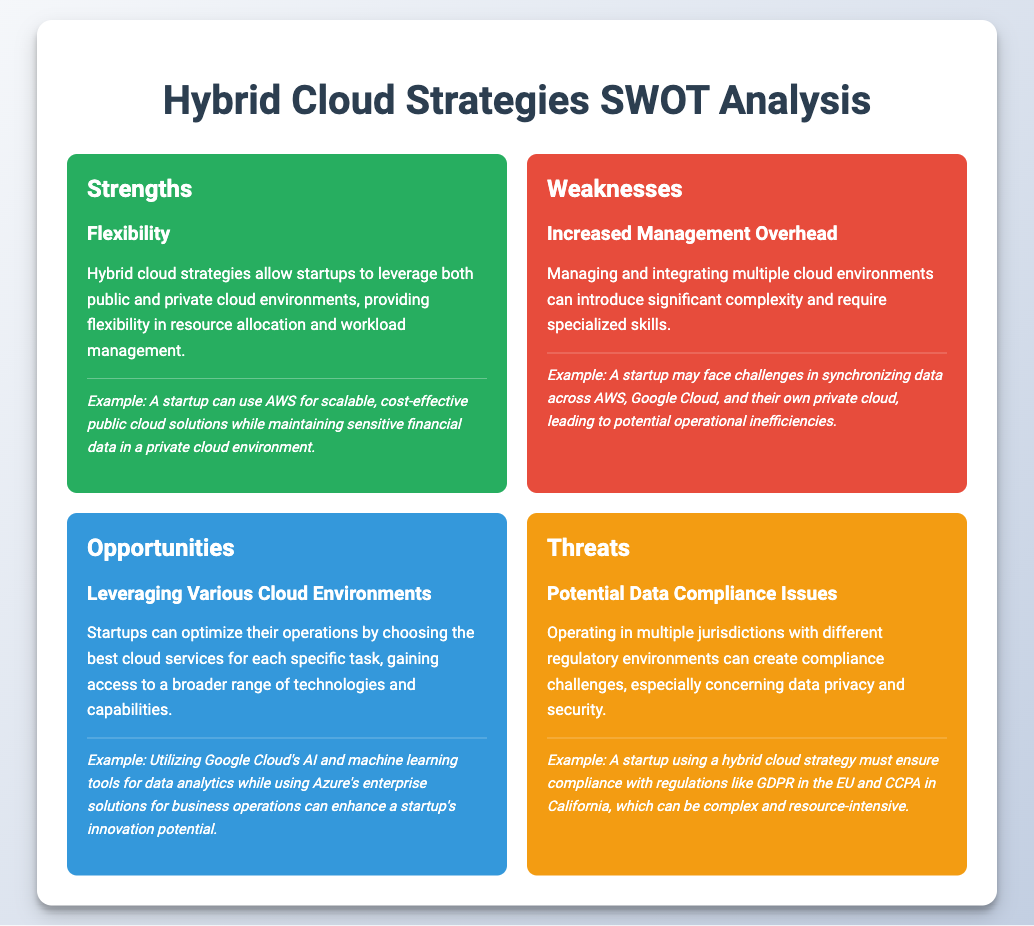What is a key strength of hybrid cloud strategies? The document highlights flexibility as a key strength of hybrid cloud strategies, allowing startups to leverage both public and private cloud environments.
Answer: Flexibility What is a noted weakness of hybrid cloud strategies? The document states that increased management overhead is a noted weakness that comes with managing and integrating multiple cloud environments.
Answer: Increased Management Overhead What opportunity is available for startups using hybrid cloud strategies? According to the document, leveraging various cloud environments is an opportunity that can enhance operations and access to technologies.
Answer: Leveraging Various Cloud Environments What is a significant threat mentioned concerning hybrid cloud strategies? The document identifies potential data compliance issues as a significant threat for startups operating in multiple jurisdictions.
Answer: Potential Data Compliance Issues What example is given for flexibility in hybrid cloud strategies? The document provides an example of a startup using AWS for public cloud solutions while keeping sensitive data in a private cloud.
Answer: AWS for scalable, cost-effective public cloud What type of document is this? The document is a SWOT analysis that evaluates strengths, weaknesses, opportunities, and threats of hybrid cloud strategies for startups.
Answer: SWOT analysis How does increased management overhead affect startups? The document states that increased management overhead can introduce complexity and require specialized skills for startups.
Answer: Introduce complexity What example does the document give for leveraging various cloud environments? The document mentions utilizing Google Cloud's AI tools for data analytics while using Azure's enterprise solutions as an example.
Answer: Google Cloud's AI and machine learning tools Which regulatory issues are startups concerned with using hybrid cloud strategies? The document lists GDPR and CCPA as regulatory issues that startups must ensure compliance with when using hybrid cloud strategies.
Answer: GDPR and CCPA 